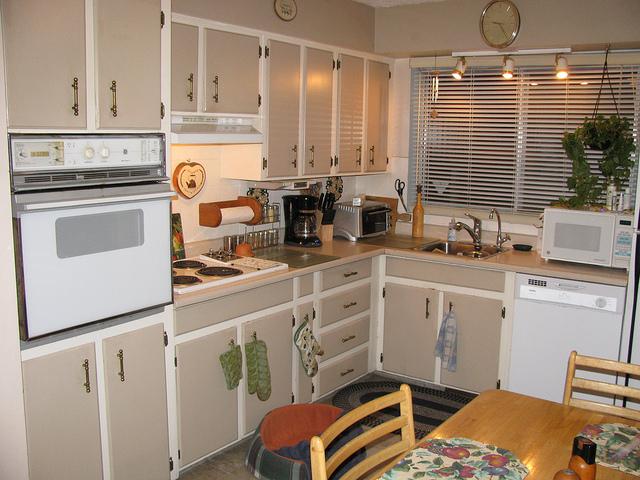What time is on the clock?
Write a very short answer. 9:25. Is microwave stainless steel?
Answer briefly. No. What is covering the windows?
Keep it brief. Blinds. How many oven mitts are hanging on cupboards?
Keep it brief. 3. 